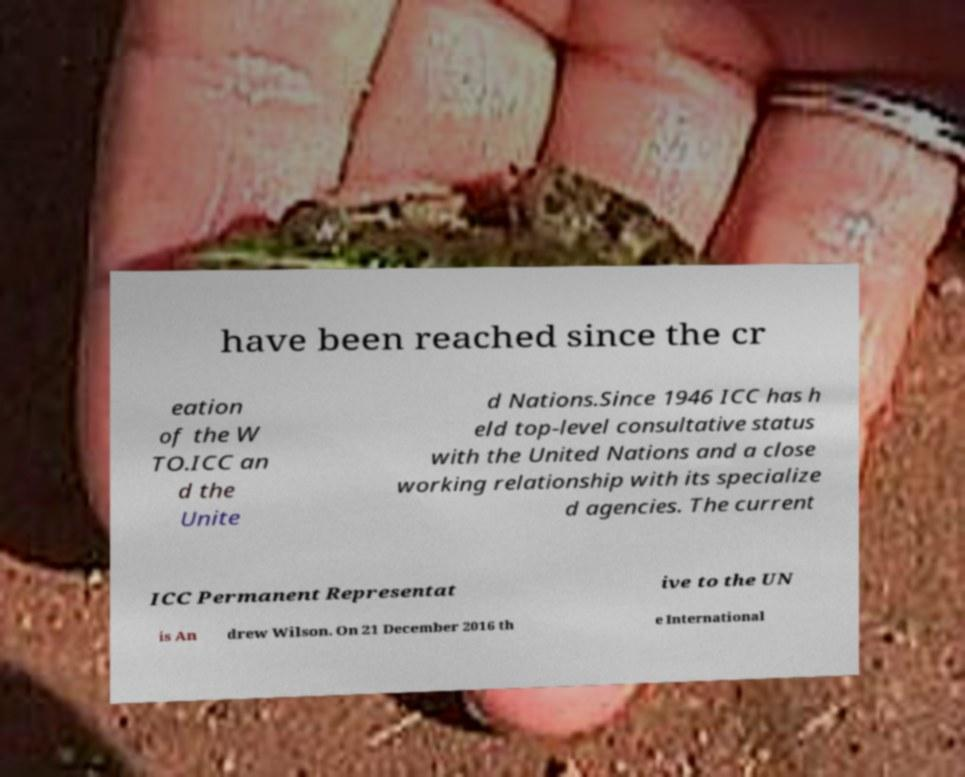I need the written content from this picture converted into text. Can you do that? have been reached since the cr eation of the W TO.ICC an d the Unite d Nations.Since 1946 ICC has h eld top-level consultative status with the United Nations and a close working relationship with its specialize d agencies. The current ICC Permanent Representat ive to the UN is An drew Wilson. On 21 December 2016 th e International 